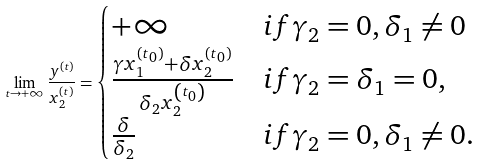Convert formula to latex. <formula><loc_0><loc_0><loc_500><loc_500>\lim _ { t \rightarrow + \infty } \frac { y ^ { ( t ) } } { x _ { 2 } ^ { ( t ) } } = \begin{cases} + \infty & i f \gamma _ { 2 } = 0 , \delta _ { 1 } \neq 0 \\ \frac { \gamma x _ { 1 } ^ { ( t _ { 0 } ) } + \delta x _ { 2 } ^ { ( t _ { 0 } ) } } { \delta _ { 2 } x _ { 2 } ^ { \left ( t _ { 0 } \right ) } } & i f \gamma _ { 2 } = \delta _ { 1 } = 0 , \\ \frac { \delta } { \delta _ { 2 } } & i f \gamma _ { 2 } = 0 , \delta _ { 1 } \neq 0 . \end{cases}</formula> 